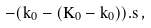Convert formula to latex. <formula><loc_0><loc_0><loc_500><loc_500>- ( k _ { 0 } - ( K _ { 0 } - k _ { 0 } ) ) . s \, ,</formula> 